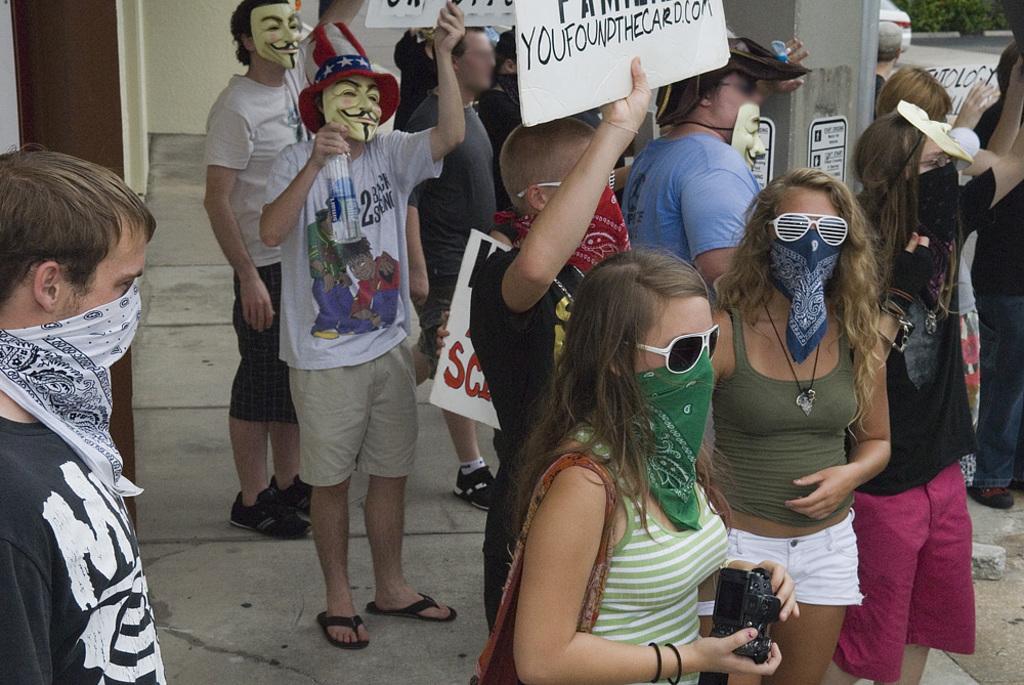Please provide a concise description of this image. In this image we can see a group of persons and among them few people are holding objects. Behind the persons we can see a wall and a pillar. On the top right, we can see a few plants and a vehicle. 